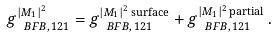<formula> <loc_0><loc_0><loc_500><loc_500>g _ { \ B F B , \, 1 2 1 } ^ { | M _ { 1 } | ^ { 2 } } = g _ { \ B F B , \, 1 2 1 } ^ { | M _ { 1 } | ^ { 2 } \, \text {surface} } + g _ { \ B F B , \, 1 2 1 } ^ { | M _ { 1 } | ^ { 2 } \, \text {partial} } \, .</formula> 